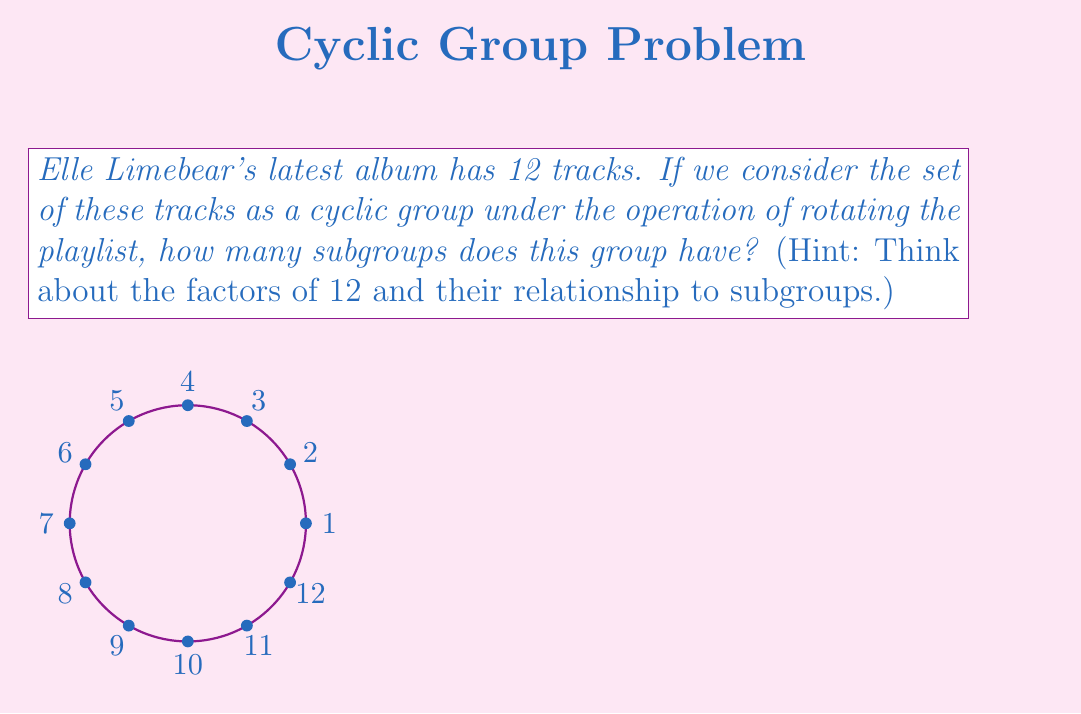Could you help me with this problem? Let's approach this step-by-step:

1) First, recall that in a cyclic group of order $n$, the number of subgroups is equal to the number of divisors of $n$.

2) In this case, $n = 12$, so we need to find the divisors of 12.

3) The divisors of 12 are: 1, 2, 3, 4, 6, and 12.

4) To understand why these correspond to subgroups:
   - The subgroup of order 1 is the trivial subgroup {e}.
   - The subgroup of order 2 is generated by rotating 6 tracks (half the playlist).
   - The subgroup of order 3 is generated by rotating 4 tracks.
   - The subgroup of order 4 is generated by rotating 3 tracks.
   - The subgroup of order 6 is generated by rotating 2 tracks.
   - The subgroup of order 12 is the entire group, generated by rotating 1 track.

5) Each of these rotations generates a unique subgroup.

6) Therefore, the number of subgroups is equal to the number of divisors of 12.

7) We counted 6 divisors of 12.

Thus, there are 6 subgroups in this cyclic group of order 12.
Answer: 6 